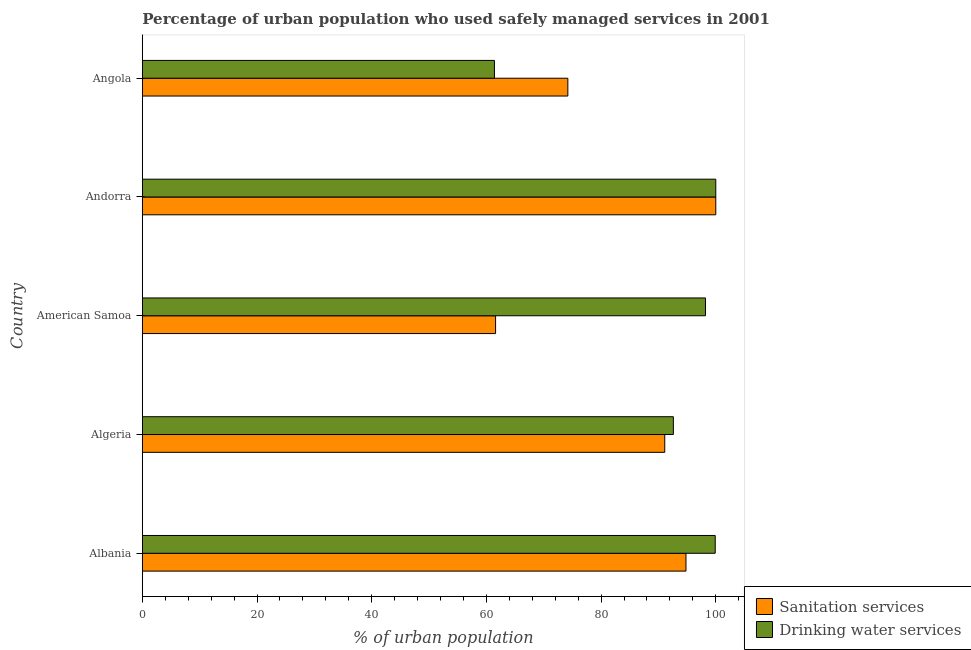How many different coloured bars are there?
Offer a terse response. 2. How many groups of bars are there?
Ensure brevity in your answer.  5. Are the number of bars per tick equal to the number of legend labels?
Provide a succinct answer. Yes. Are the number of bars on each tick of the Y-axis equal?
Offer a very short reply. Yes. How many bars are there on the 1st tick from the bottom?
Make the answer very short. 2. What is the label of the 1st group of bars from the top?
Provide a succinct answer. Angola. In how many cases, is the number of bars for a given country not equal to the number of legend labels?
Offer a terse response. 0. What is the percentage of urban population who used sanitation services in Albania?
Ensure brevity in your answer.  94.8. Across all countries, what is the minimum percentage of urban population who used sanitation services?
Offer a very short reply. 61.6. In which country was the percentage of urban population who used drinking water services maximum?
Your answer should be very brief. Andorra. In which country was the percentage of urban population who used drinking water services minimum?
Give a very brief answer. Angola. What is the total percentage of urban population who used sanitation services in the graph?
Your response must be concise. 421.7. What is the difference between the percentage of urban population who used sanitation services in Albania and that in American Samoa?
Offer a terse response. 33.2. What is the difference between the percentage of urban population who used sanitation services in Angola and the percentage of urban population who used drinking water services in Albania?
Provide a succinct answer. -25.7. What is the average percentage of urban population who used sanitation services per country?
Ensure brevity in your answer.  84.34. In how many countries, is the percentage of urban population who used sanitation services greater than 16 %?
Your response must be concise. 5. What is the ratio of the percentage of urban population who used sanitation services in American Samoa to that in Andorra?
Ensure brevity in your answer.  0.62. Is the percentage of urban population who used sanitation services in Albania less than that in Angola?
Give a very brief answer. No. What is the difference between the highest and the second highest percentage of urban population who used drinking water services?
Your answer should be compact. 0.1. What is the difference between the highest and the lowest percentage of urban population who used drinking water services?
Provide a short and direct response. 38.6. In how many countries, is the percentage of urban population who used drinking water services greater than the average percentage of urban population who used drinking water services taken over all countries?
Offer a terse response. 4. Is the sum of the percentage of urban population who used drinking water services in Algeria and Angola greater than the maximum percentage of urban population who used sanitation services across all countries?
Make the answer very short. Yes. What does the 2nd bar from the top in Albania represents?
Keep it short and to the point. Sanitation services. What does the 2nd bar from the bottom in Angola represents?
Give a very brief answer. Drinking water services. How many bars are there?
Provide a succinct answer. 10. How many countries are there in the graph?
Ensure brevity in your answer.  5. Are the values on the major ticks of X-axis written in scientific E-notation?
Provide a succinct answer. No. Does the graph contain any zero values?
Keep it short and to the point. No. Does the graph contain grids?
Your answer should be compact. No. Where does the legend appear in the graph?
Keep it short and to the point. Bottom right. How many legend labels are there?
Offer a terse response. 2. How are the legend labels stacked?
Your answer should be very brief. Vertical. What is the title of the graph?
Your response must be concise. Percentage of urban population who used safely managed services in 2001. What is the label or title of the X-axis?
Keep it short and to the point. % of urban population. What is the % of urban population in Sanitation services in Albania?
Give a very brief answer. 94.8. What is the % of urban population in Drinking water services in Albania?
Keep it short and to the point. 99.9. What is the % of urban population of Sanitation services in Algeria?
Your answer should be very brief. 91.1. What is the % of urban population in Drinking water services in Algeria?
Offer a very short reply. 92.6. What is the % of urban population of Sanitation services in American Samoa?
Your response must be concise. 61.6. What is the % of urban population in Drinking water services in American Samoa?
Provide a succinct answer. 98.2. What is the % of urban population of Sanitation services in Angola?
Give a very brief answer. 74.2. What is the % of urban population of Drinking water services in Angola?
Offer a very short reply. 61.4. Across all countries, what is the minimum % of urban population in Sanitation services?
Your answer should be compact. 61.6. Across all countries, what is the minimum % of urban population of Drinking water services?
Make the answer very short. 61.4. What is the total % of urban population of Sanitation services in the graph?
Your answer should be compact. 421.7. What is the total % of urban population of Drinking water services in the graph?
Make the answer very short. 452.1. What is the difference between the % of urban population of Sanitation services in Albania and that in Algeria?
Your answer should be very brief. 3.7. What is the difference between the % of urban population of Sanitation services in Albania and that in American Samoa?
Keep it short and to the point. 33.2. What is the difference between the % of urban population of Sanitation services in Albania and that in Andorra?
Your response must be concise. -5.2. What is the difference between the % of urban population of Drinking water services in Albania and that in Andorra?
Offer a very short reply. -0.1. What is the difference between the % of urban population in Sanitation services in Albania and that in Angola?
Offer a terse response. 20.6. What is the difference between the % of urban population in Drinking water services in Albania and that in Angola?
Ensure brevity in your answer.  38.5. What is the difference between the % of urban population in Sanitation services in Algeria and that in American Samoa?
Provide a short and direct response. 29.5. What is the difference between the % of urban population in Drinking water services in Algeria and that in American Samoa?
Keep it short and to the point. -5.6. What is the difference between the % of urban population of Drinking water services in Algeria and that in Andorra?
Give a very brief answer. -7.4. What is the difference between the % of urban population in Drinking water services in Algeria and that in Angola?
Keep it short and to the point. 31.2. What is the difference between the % of urban population in Sanitation services in American Samoa and that in Andorra?
Your answer should be very brief. -38.4. What is the difference between the % of urban population in Sanitation services in American Samoa and that in Angola?
Give a very brief answer. -12.6. What is the difference between the % of urban population of Drinking water services in American Samoa and that in Angola?
Your answer should be compact. 36.8. What is the difference between the % of urban population of Sanitation services in Andorra and that in Angola?
Make the answer very short. 25.8. What is the difference between the % of urban population in Drinking water services in Andorra and that in Angola?
Provide a succinct answer. 38.6. What is the difference between the % of urban population of Sanitation services in Albania and the % of urban population of Drinking water services in Angola?
Offer a terse response. 33.4. What is the difference between the % of urban population of Sanitation services in Algeria and the % of urban population of Drinking water services in Angola?
Your response must be concise. 29.7. What is the difference between the % of urban population of Sanitation services in American Samoa and the % of urban population of Drinking water services in Andorra?
Offer a very short reply. -38.4. What is the difference between the % of urban population in Sanitation services in American Samoa and the % of urban population in Drinking water services in Angola?
Offer a very short reply. 0.2. What is the difference between the % of urban population of Sanitation services in Andorra and the % of urban population of Drinking water services in Angola?
Provide a succinct answer. 38.6. What is the average % of urban population in Sanitation services per country?
Provide a succinct answer. 84.34. What is the average % of urban population of Drinking water services per country?
Keep it short and to the point. 90.42. What is the difference between the % of urban population of Sanitation services and % of urban population of Drinking water services in Algeria?
Provide a succinct answer. -1.5. What is the difference between the % of urban population in Sanitation services and % of urban population in Drinking water services in American Samoa?
Your answer should be very brief. -36.6. What is the difference between the % of urban population in Sanitation services and % of urban population in Drinking water services in Andorra?
Your answer should be compact. 0. What is the difference between the % of urban population of Sanitation services and % of urban population of Drinking water services in Angola?
Your response must be concise. 12.8. What is the ratio of the % of urban population of Sanitation services in Albania to that in Algeria?
Make the answer very short. 1.04. What is the ratio of the % of urban population of Drinking water services in Albania to that in Algeria?
Ensure brevity in your answer.  1.08. What is the ratio of the % of urban population in Sanitation services in Albania to that in American Samoa?
Offer a terse response. 1.54. What is the ratio of the % of urban population in Drinking water services in Albania to that in American Samoa?
Your response must be concise. 1.02. What is the ratio of the % of urban population of Sanitation services in Albania to that in Andorra?
Provide a succinct answer. 0.95. What is the ratio of the % of urban population in Sanitation services in Albania to that in Angola?
Ensure brevity in your answer.  1.28. What is the ratio of the % of urban population of Drinking water services in Albania to that in Angola?
Your answer should be compact. 1.63. What is the ratio of the % of urban population in Sanitation services in Algeria to that in American Samoa?
Offer a very short reply. 1.48. What is the ratio of the % of urban population in Drinking water services in Algeria to that in American Samoa?
Your answer should be very brief. 0.94. What is the ratio of the % of urban population of Sanitation services in Algeria to that in Andorra?
Give a very brief answer. 0.91. What is the ratio of the % of urban population of Drinking water services in Algeria to that in Andorra?
Your response must be concise. 0.93. What is the ratio of the % of urban population of Sanitation services in Algeria to that in Angola?
Your response must be concise. 1.23. What is the ratio of the % of urban population in Drinking water services in Algeria to that in Angola?
Your answer should be very brief. 1.51. What is the ratio of the % of urban population in Sanitation services in American Samoa to that in Andorra?
Ensure brevity in your answer.  0.62. What is the ratio of the % of urban population in Drinking water services in American Samoa to that in Andorra?
Your answer should be compact. 0.98. What is the ratio of the % of urban population in Sanitation services in American Samoa to that in Angola?
Offer a terse response. 0.83. What is the ratio of the % of urban population of Drinking water services in American Samoa to that in Angola?
Offer a terse response. 1.6. What is the ratio of the % of urban population in Sanitation services in Andorra to that in Angola?
Offer a very short reply. 1.35. What is the ratio of the % of urban population of Drinking water services in Andorra to that in Angola?
Your response must be concise. 1.63. What is the difference between the highest and the second highest % of urban population in Sanitation services?
Your answer should be very brief. 5.2. What is the difference between the highest and the second highest % of urban population of Drinking water services?
Offer a terse response. 0.1. What is the difference between the highest and the lowest % of urban population in Sanitation services?
Provide a succinct answer. 38.4. What is the difference between the highest and the lowest % of urban population in Drinking water services?
Offer a very short reply. 38.6. 